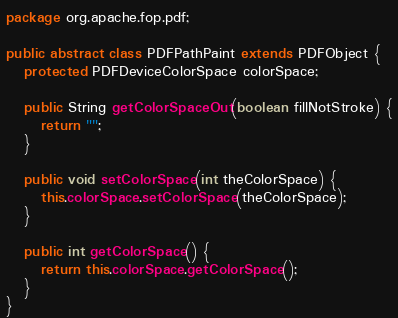<code> <loc_0><loc_0><loc_500><loc_500><_Java_>package org.apache.fop.pdf;

public abstract class PDFPathPaint extends PDFObject {
   protected PDFDeviceColorSpace colorSpace;

   public String getColorSpaceOut(boolean fillNotStroke) {
      return "";
   }

   public void setColorSpace(int theColorSpace) {
      this.colorSpace.setColorSpace(theColorSpace);
   }

   public int getColorSpace() {
      return this.colorSpace.getColorSpace();
   }
}
</code> 